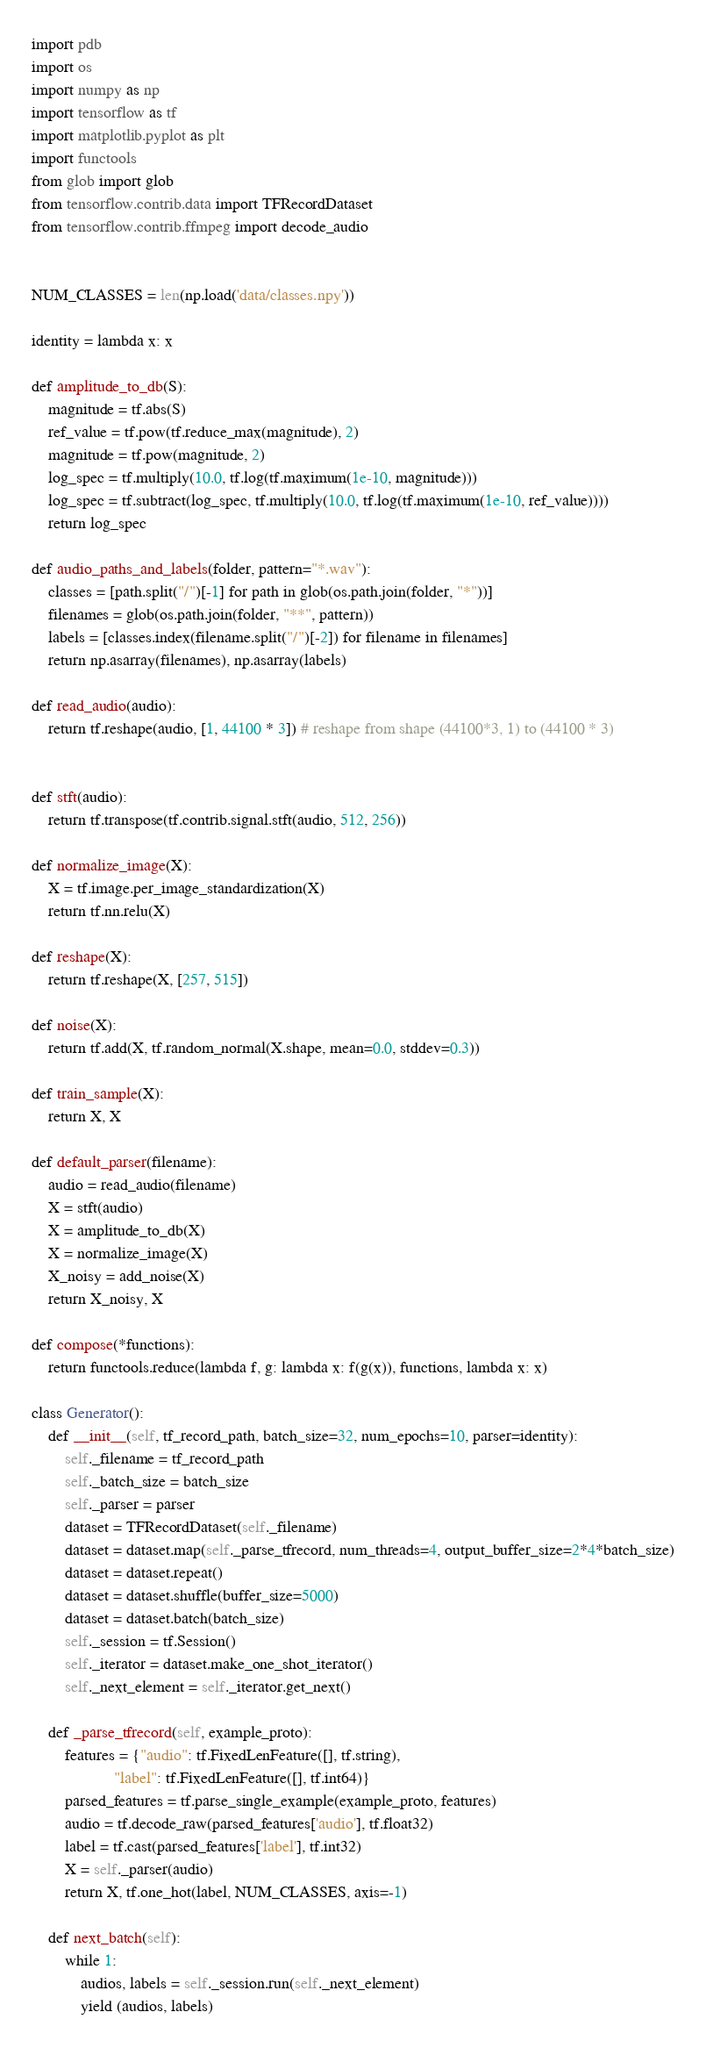<code> <loc_0><loc_0><loc_500><loc_500><_Python_>import pdb
import os
import numpy as np
import tensorflow as tf
import matplotlib.pyplot as plt
import functools
from glob import glob
from tensorflow.contrib.data import TFRecordDataset
from tensorflow.contrib.ffmpeg import decode_audio


NUM_CLASSES = len(np.load('data/classes.npy'))

identity = lambda x: x

def amplitude_to_db(S):
    magnitude = tf.abs(S)
    ref_value = tf.pow(tf.reduce_max(magnitude), 2)
    magnitude = tf.pow(magnitude, 2)
    log_spec = tf.multiply(10.0, tf.log(tf.maximum(1e-10, magnitude)))
    log_spec = tf.subtract(log_spec, tf.multiply(10.0, tf.log(tf.maximum(1e-10, ref_value))))
    return log_spec

def audio_paths_and_labels(folder, pattern="*.wav"):
    classes = [path.split("/")[-1] for path in glob(os.path.join(folder, "*"))]
    filenames = glob(os.path.join(folder, "**", pattern))
    labels = [classes.index(filename.split("/")[-2]) for filename in filenames]
    return np.asarray(filenames), np.asarray(labels)

def read_audio(audio):
    return tf.reshape(audio, [1, 44100 * 3]) # reshape from shape (44100*3, 1) to (44100 * 3)


def stft(audio):
    return tf.transpose(tf.contrib.signal.stft(audio, 512, 256))

def normalize_image(X):
    X = tf.image.per_image_standardization(X)
    return tf.nn.relu(X)

def reshape(X):
    return tf.reshape(X, [257, 515])

def noise(X):
    return tf.add(X, tf.random_normal(X.shape, mean=0.0, stddev=0.3))

def train_sample(X):
    return X, X

def default_parser(filename):
    audio = read_audio(filename)
    X = stft(audio)
    X = amplitude_to_db(X)
    X = normalize_image(X)
    X_noisy = add_noise(X)
    return X_noisy, X

def compose(*functions):
    return functools.reduce(lambda f, g: lambda x: f(g(x)), functions, lambda x: x)

class Generator():
    def __init__(self, tf_record_path, batch_size=32, num_epochs=10, parser=identity):
        self._filename = tf_record_path
        self._batch_size = batch_size
        self._parser = parser
        dataset = TFRecordDataset(self._filename)
        dataset = dataset.map(self._parse_tfrecord, num_threads=4, output_buffer_size=2*4*batch_size)
        dataset = dataset.repeat()
        dataset = dataset.shuffle(buffer_size=5000)
        dataset = dataset.batch(batch_size)
        self._session = tf.Session()
        self._iterator = dataset.make_one_shot_iterator()
        self._next_element = self._iterator.get_next()

    def _parse_tfrecord(self, example_proto):
        features = {"audio": tf.FixedLenFeature([], tf.string),
                    "label": tf.FixedLenFeature([], tf.int64)}
        parsed_features = tf.parse_single_example(example_proto, features)
        audio = tf.decode_raw(parsed_features['audio'], tf.float32)
        label = tf.cast(parsed_features['label'], tf.int32)
        X = self._parser(audio)
        return X, tf.one_hot(label, NUM_CLASSES, axis=-1)

    def next_batch(self):
        while 1:
            audios, labels = self._session.run(self._next_element)
            yield (audios, labels)
</code> 